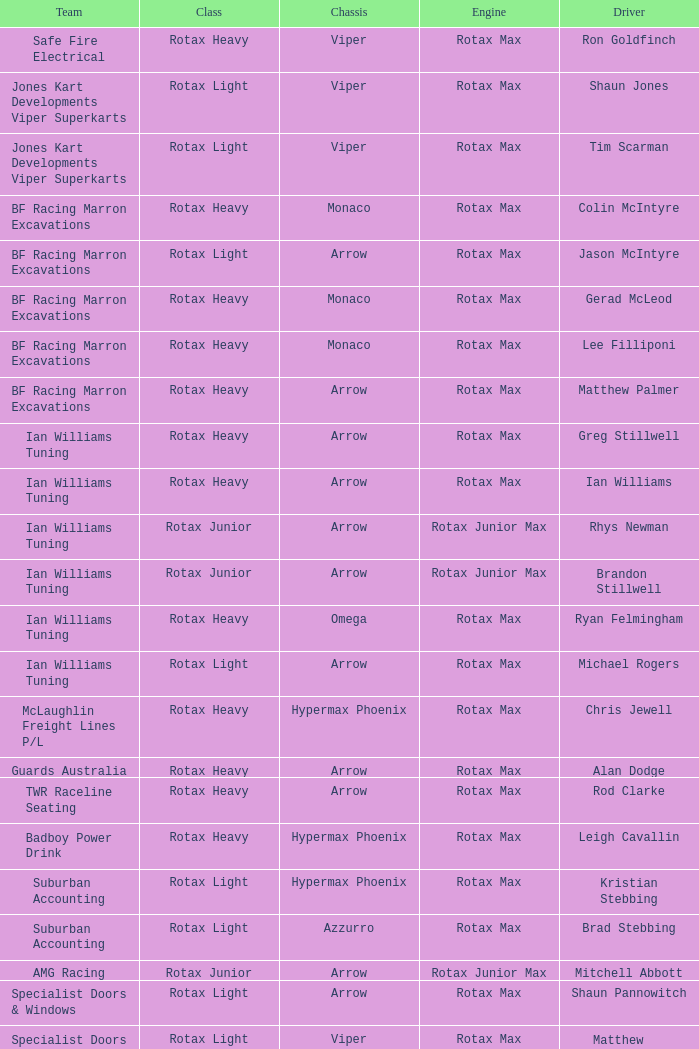What sort of engine is equipped in the bf racing marron excavations, which has monaco as the framework and lee filliponi as the chauffeur? Rotax Max. 